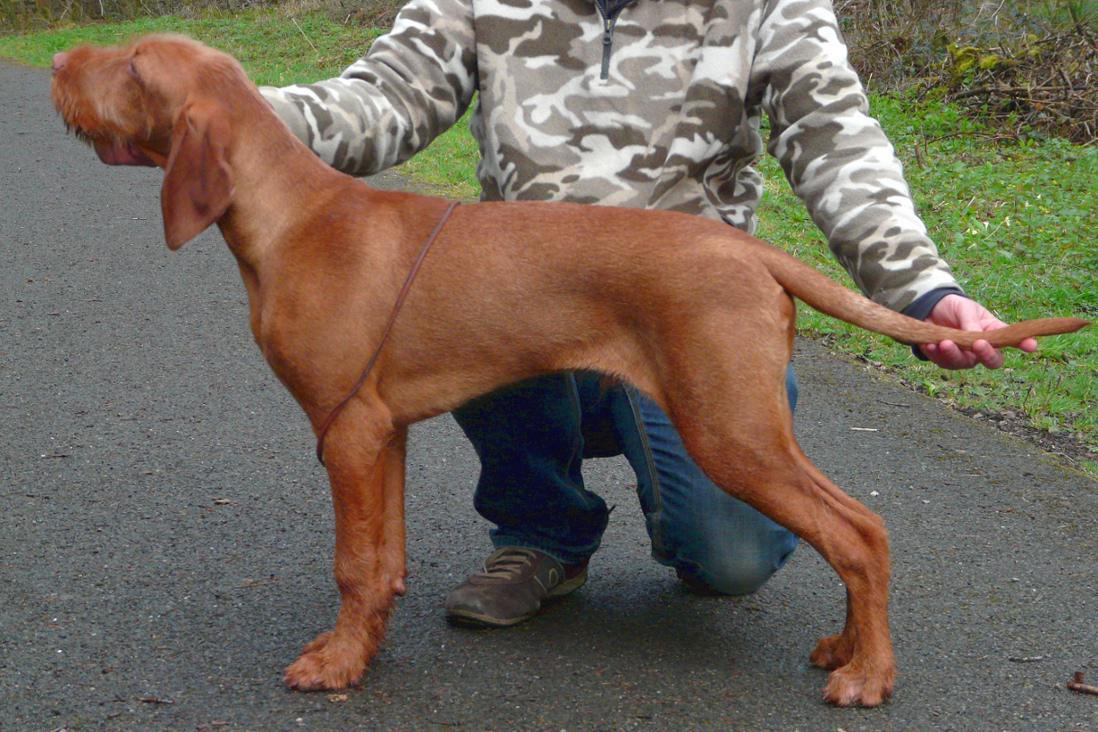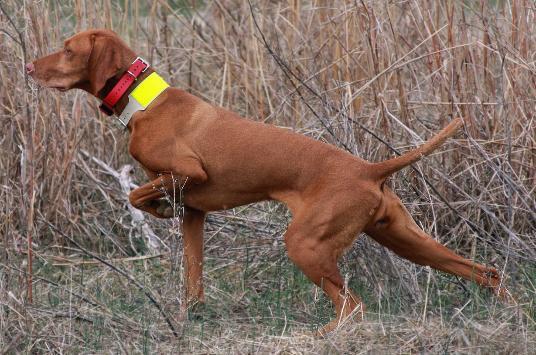The first image is the image on the left, the second image is the image on the right. For the images displayed, is the sentence "There are two dogs with their mouths closed." factually correct? Answer yes or no. Yes. The first image is the image on the left, the second image is the image on the right. Examine the images to the left and right. Is the description "At least one dog is on a leash." accurate? Answer yes or no. No. 